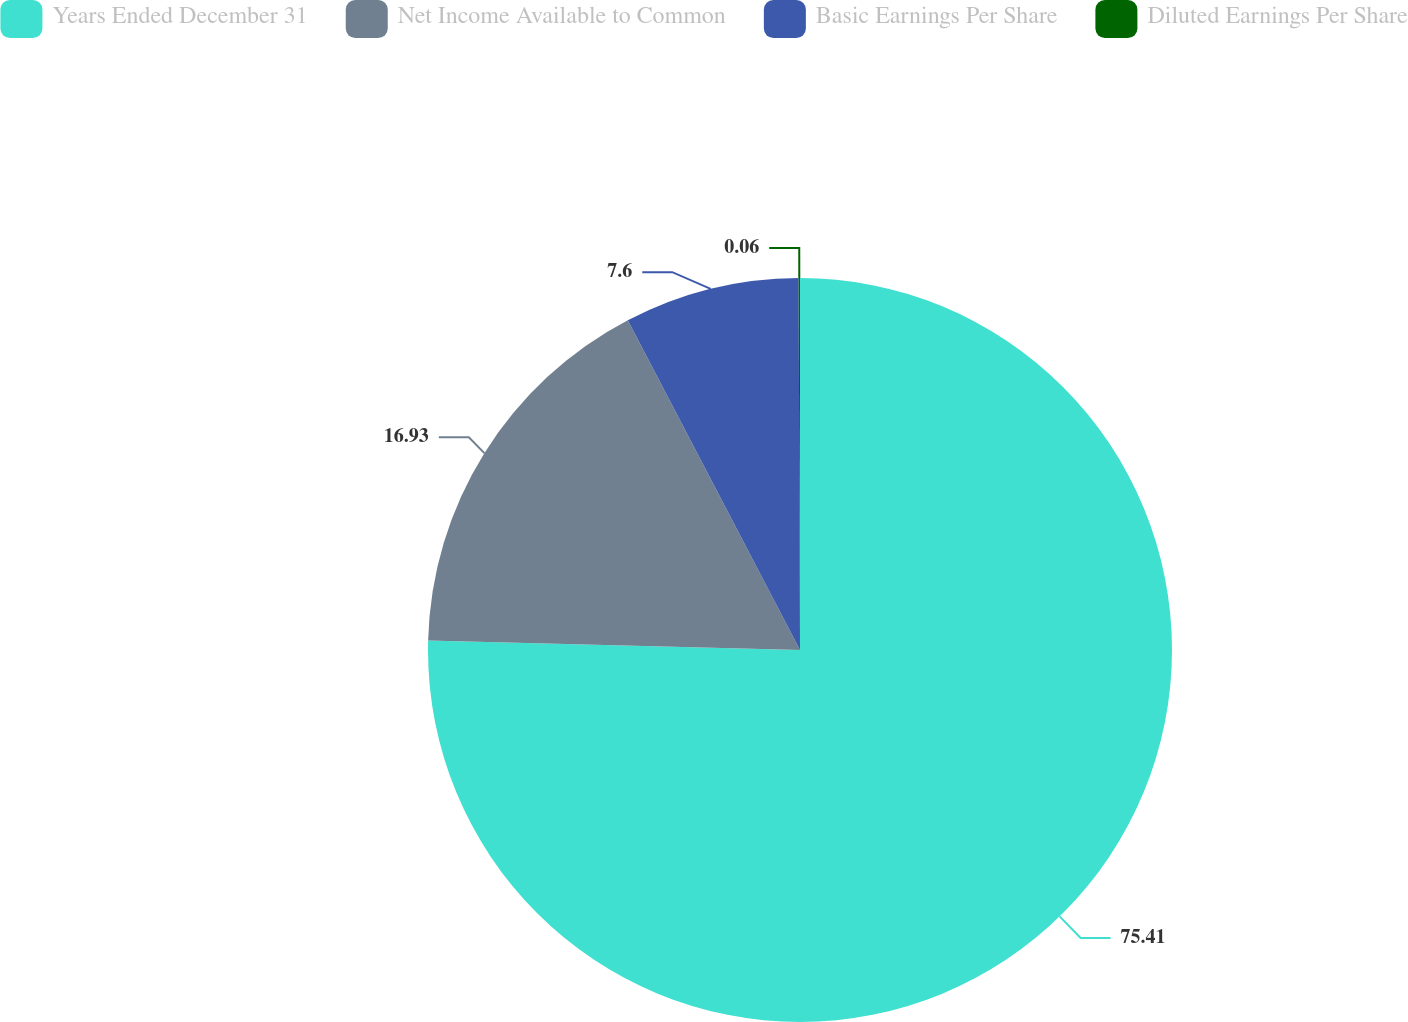Convert chart to OTSL. <chart><loc_0><loc_0><loc_500><loc_500><pie_chart><fcel>Years Ended December 31<fcel>Net Income Available to Common<fcel>Basic Earnings Per Share<fcel>Diluted Earnings Per Share<nl><fcel>75.41%<fcel>16.93%<fcel>7.6%<fcel>0.06%<nl></chart> 